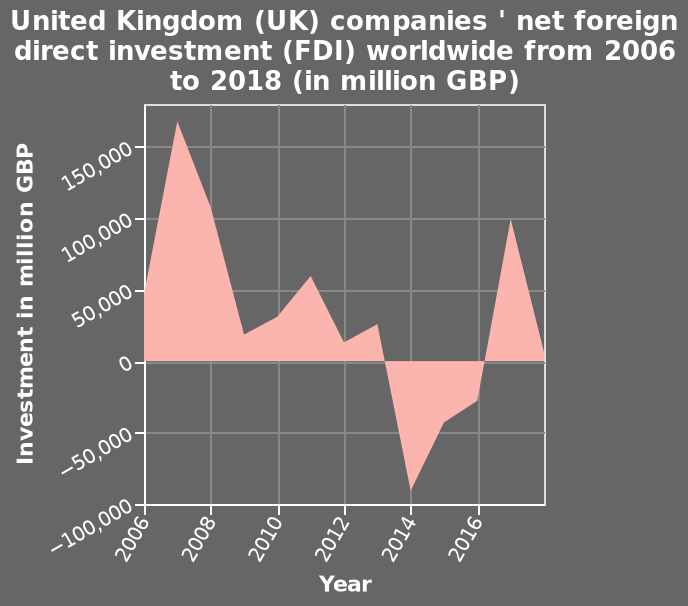<image>
please enumerates aspects of the construction of the chart United Kingdom (UK) companies ' net foreign direct investment (FDI) worldwide from 2006 to 2018 (in million GBP) is a area chart. Investment in million GBP is measured along the y-axis. On the x-axis, Year is defined as a linear scale of range 2006 to 2016. Offer a thorough analysis of the image. In 2009 the FDI reached its highest of 180000 million GDP. In 2014 the FDI reached its lowest of 85000 million GDP. Most years are between 0 and 100000 million GDP. What is being measured along the y-axis? Investment in million GBP is being measured along the y-axis. 